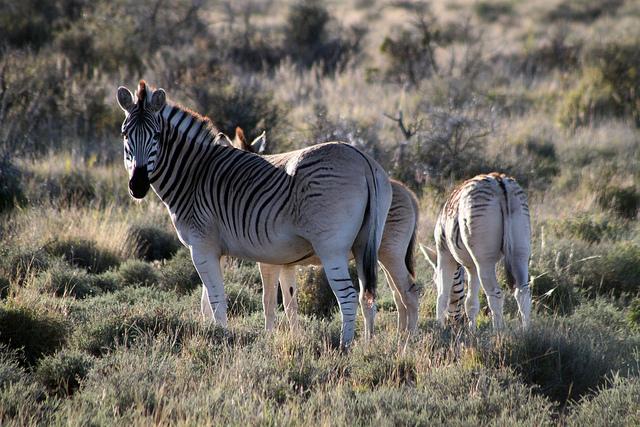Are all the zebras facing the camera?
Quick response, please. No. Is the zebra on the right eating grass?
Answer briefly. Yes. Is one of the zebras looking at the camera?
Keep it brief. Yes. 